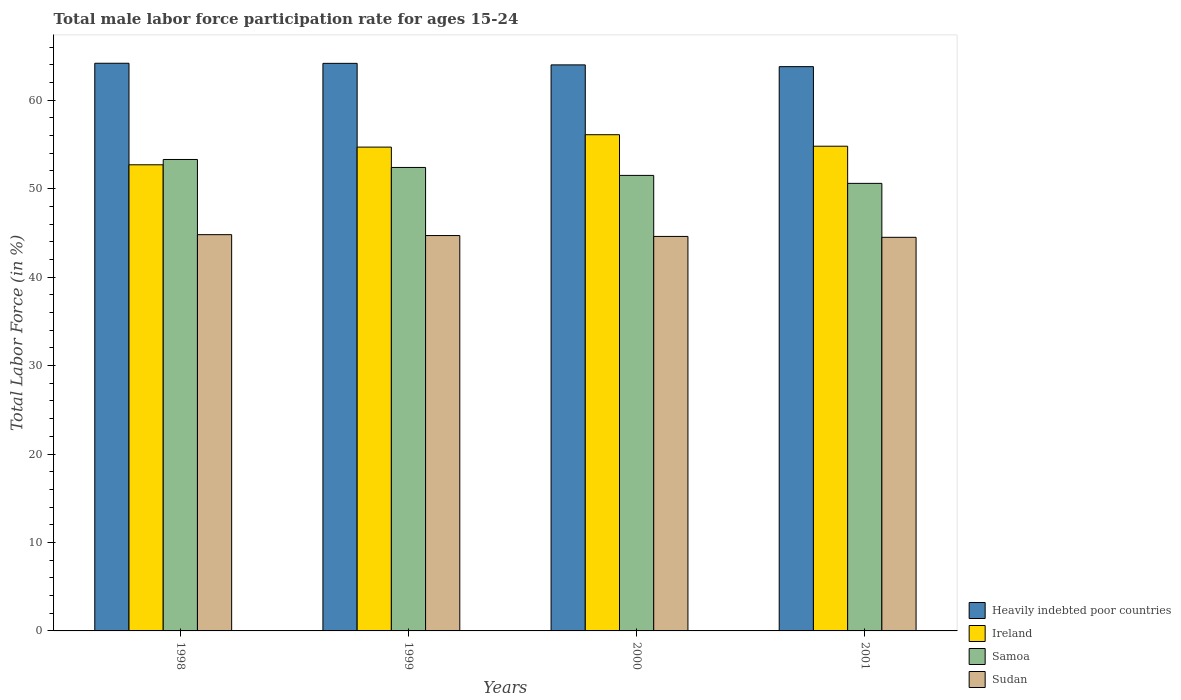How many groups of bars are there?
Make the answer very short. 4. Are the number of bars on each tick of the X-axis equal?
Give a very brief answer. Yes. How many bars are there on the 2nd tick from the right?
Your response must be concise. 4. In how many cases, is the number of bars for a given year not equal to the number of legend labels?
Your response must be concise. 0. What is the male labor force participation rate in Sudan in 1999?
Offer a very short reply. 44.7. Across all years, what is the maximum male labor force participation rate in Samoa?
Your response must be concise. 53.3. Across all years, what is the minimum male labor force participation rate in Heavily indebted poor countries?
Give a very brief answer. 63.8. In which year was the male labor force participation rate in Sudan minimum?
Offer a terse response. 2001. What is the total male labor force participation rate in Sudan in the graph?
Offer a terse response. 178.6. What is the difference between the male labor force participation rate in Ireland in 1999 and that in 2000?
Your answer should be very brief. -1.4. What is the difference between the male labor force participation rate in Ireland in 1998 and the male labor force participation rate in Samoa in 2001?
Keep it short and to the point. 2.1. What is the average male labor force participation rate in Ireland per year?
Provide a short and direct response. 54.57. In the year 1998, what is the difference between the male labor force participation rate in Heavily indebted poor countries and male labor force participation rate in Samoa?
Offer a very short reply. 10.88. In how many years, is the male labor force participation rate in Ireland greater than 48 %?
Ensure brevity in your answer.  4. What is the ratio of the male labor force participation rate in Ireland in 2000 to that in 2001?
Provide a succinct answer. 1.02. Is the male labor force participation rate in Ireland in 1998 less than that in 2001?
Ensure brevity in your answer.  Yes. What is the difference between the highest and the second highest male labor force participation rate in Heavily indebted poor countries?
Your answer should be compact. 0.01. What is the difference between the highest and the lowest male labor force participation rate in Ireland?
Ensure brevity in your answer.  3.4. In how many years, is the male labor force participation rate in Samoa greater than the average male labor force participation rate in Samoa taken over all years?
Your response must be concise. 2. Is the sum of the male labor force participation rate in Sudan in 1998 and 2001 greater than the maximum male labor force participation rate in Ireland across all years?
Your answer should be compact. Yes. What does the 3rd bar from the left in 1999 represents?
Provide a short and direct response. Samoa. What does the 3rd bar from the right in 2000 represents?
Provide a short and direct response. Ireland. How many bars are there?
Your answer should be compact. 16. What is the difference between two consecutive major ticks on the Y-axis?
Your answer should be compact. 10. Where does the legend appear in the graph?
Your answer should be very brief. Bottom right. How many legend labels are there?
Ensure brevity in your answer.  4. What is the title of the graph?
Provide a short and direct response. Total male labor force participation rate for ages 15-24. What is the label or title of the X-axis?
Offer a terse response. Years. What is the label or title of the Y-axis?
Give a very brief answer. Total Labor Force (in %). What is the Total Labor Force (in %) of Heavily indebted poor countries in 1998?
Make the answer very short. 64.18. What is the Total Labor Force (in %) of Ireland in 1998?
Your answer should be compact. 52.7. What is the Total Labor Force (in %) of Samoa in 1998?
Keep it short and to the point. 53.3. What is the Total Labor Force (in %) of Sudan in 1998?
Give a very brief answer. 44.8. What is the Total Labor Force (in %) in Heavily indebted poor countries in 1999?
Offer a very short reply. 64.17. What is the Total Labor Force (in %) of Ireland in 1999?
Your answer should be compact. 54.7. What is the Total Labor Force (in %) of Samoa in 1999?
Provide a succinct answer. 52.4. What is the Total Labor Force (in %) in Sudan in 1999?
Ensure brevity in your answer.  44.7. What is the Total Labor Force (in %) in Heavily indebted poor countries in 2000?
Keep it short and to the point. 63.99. What is the Total Labor Force (in %) in Ireland in 2000?
Your response must be concise. 56.1. What is the Total Labor Force (in %) of Samoa in 2000?
Give a very brief answer. 51.5. What is the Total Labor Force (in %) in Sudan in 2000?
Offer a terse response. 44.6. What is the Total Labor Force (in %) in Heavily indebted poor countries in 2001?
Give a very brief answer. 63.8. What is the Total Labor Force (in %) of Ireland in 2001?
Provide a succinct answer. 54.8. What is the Total Labor Force (in %) in Samoa in 2001?
Your answer should be compact. 50.6. What is the Total Labor Force (in %) of Sudan in 2001?
Provide a short and direct response. 44.5. Across all years, what is the maximum Total Labor Force (in %) of Heavily indebted poor countries?
Offer a very short reply. 64.18. Across all years, what is the maximum Total Labor Force (in %) of Ireland?
Give a very brief answer. 56.1. Across all years, what is the maximum Total Labor Force (in %) of Samoa?
Provide a short and direct response. 53.3. Across all years, what is the maximum Total Labor Force (in %) of Sudan?
Offer a terse response. 44.8. Across all years, what is the minimum Total Labor Force (in %) in Heavily indebted poor countries?
Your answer should be compact. 63.8. Across all years, what is the minimum Total Labor Force (in %) in Ireland?
Keep it short and to the point. 52.7. Across all years, what is the minimum Total Labor Force (in %) of Samoa?
Give a very brief answer. 50.6. Across all years, what is the minimum Total Labor Force (in %) of Sudan?
Keep it short and to the point. 44.5. What is the total Total Labor Force (in %) in Heavily indebted poor countries in the graph?
Give a very brief answer. 256.14. What is the total Total Labor Force (in %) in Ireland in the graph?
Your answer should be compact. 218.3. What is the total Total Labor Force (in %) of Samoa in the graph?
Make the answer very short. 207.8. What is the total Total Labor Force (in %) of Sudan in the graph?
Provide a succinct answer. 178.6. What is the difference between the Total Labor Force (in %) of Heavily indebted poor countries in 1998 and that in 1999?
Offer a very short reply. 0.01. What is the difference between the Total Labor Force (in %) in Heavily indebted poor countries in 1998 and that in 2000?
Your answer should be very brief. 0.18. What is the difference between the Total Labor Force (in %) in Ireland in 1998 and that in 2000?
Your response must be concise. -3.4. What is the difference between the Total Labor Force (in %) of Samoa in 1998 and that in 2000?
Ensure brevity in your answer.  1.8. What is the difference between the Total Labor Force (in %) of Heavily indebted poor countries in 1998 and that in 2001?
Your response must be concise. 0.38. What is the difference between the Total Labor Force (in %) of Ireland in 1998 and that in 2001?
Offer a very short reply. -2.1. What is the difference between the Total Labor Force (in %) in Heavily indebted poor countries in 1999 and that in 2000?
Provide a succinct answer. 0.17. What is the difference between the Total Labor Force (in %) in Samoa in 1999 and that in 2000?
Give a very brief answer. 0.9. What is the difference between the Total Labor Force (in %) of Heavily indebted poor countries in 1999 and that in 2001?
Ensure brevity in your answer.  0.37. What is the difference between the Total Labor Force (in %) in Samoa in 1999 and that in 2001?
Make the answer very short. 1.8. What is the difference between the Total Labor Force (in %) of Heavily indebted poor countries in 2000 and that in 2001?
Your answer should be very brief. 0.2. What is the difference between the Total Labor Force (in %) of Heavily indebted poor countries in 1998 and the Total Labor Force (in %) of Ireland in 1999?
Provide a succinct answer. 9.48. What is the difference between the Total Labor Force (in %) in Heavily indebted poor countries in 1998 and the Total Labor Force (in %) in Samoa in 1999?
Provide a succinct answer. 11.78. What is the difference between the Total Labor Force (in %) of Heavily indebted poor countries in 1998 and the Total Labor Force (in %) of Sudan in 1999?
Provide a short and direct response. 19.48. What is the difference between the Total Labor Force (in %) of Ireland in 1998 and the Total Labor Force (in %) of Samoa in 1999?
Offer a very short reply. 0.3. What is the difference between the Total Labor Force (in %) of Ireland in 1998 and the Total Labor Force (in %) of Sudan in 1999?
Make the answer very short. 8. What is the difference between the Total Labor Force (in %) of Heavily indebted poor countries in 1998 and the Total Labor Force (in %) of Ireland in 2000?
Ensure brevity in your answer.  8.08. What is the difference between the Total Labor Force (in %) of Heavily indebted poor countries in 1998 and the Total Labor Force (in %) of Samoa in 2000?
Provide a succinct answer. 12.68. What is the difference between the Total Labor Force (in %) in Heavily indebted poor countries in 1998 and the Total Labor Force (in %) in Sudan in 2000?
Your response must be concise. 19.58. What is the difference between the Total Labor Force (in %) of Ireland in 1998 and the Total Labor Force (in %) of Samoa in 2000?
Provide a succinct answer. 1.2. What is the difference between the Total Labor Force (in %) of Ireland in 1998 and the Total Labor Force (in %) of Sudan in 2000?
Ensure brevity in your answer.  8.1. What is the difference between the Total Labor Force (in %) of Samoa in 1998 and the Total Labor Force (in %) of Sudan in 2000?
Provide a short and direct response. 8.7. What is the difference between the Total Labor Force (in %) of Heavily indebted poor countries in 1998 and the Total Labor Force (in %) of Ireland in 2001?
Make the answer very short. 9.38. What is the difference between the Total Labor Force (in %) of Heavily indebted poor countries in 1998 and the Total Labor Force (in %) of Samoa in 2001?
Ensure brevity in your answer.  13.58. What is the difference between the Total Labor Force (in %) of Heavily indebted poor countries in 1998 and the Total Labor Force (in %) of Sudan in 2001?
Your answer should be very brief. 19.68. What is the difference between the Total Labor Force (in %) in Ireland in 1998 and the Total Labor Force (in %) in Sudan in 2001?
Make the answer very short. 8.2. What is the difference between the Total Labor Force (in %) in Heavily indebted poor countries in 1999 and the Total Labor Force (in %) in Ireland in 2000?
Give a very brief answer. 8.07. What is the difference between the Total Labor Force (in %) of Heavily indebted poor countries in 1999 and the Total Labor Force (in %) of Samoa in 2000?
Your response must be concise. 12.67. What is the difference between the Total Labor Force (in %) of Heavily indebted poor countries in 1999 and the Total Labor Force (in %) of Sudan in 2000?
Make the answer very short. 19.57. What is the difference between the Total Labor Force (in %) of Ireland in 1999 and the Total Labor Force (in %) of Sudan in 2000?
Provide a short and direct response. 10.1. What is the difference between the Total Labor Force (in %) in Samoa in 1999 and the Total Labor Force (in %) in Sudan in 2000?
Offer a terse response. 7.8. What is the difference between the Total Labor Force (in %) of Heavily indebted poor countries in 1999 and the Total Labor Force (in %) of Ireland in 2001?
Your answer should be compact. 9.37. What is the difference between the Total Labor Force (in %) in Heavily indebted poor countries in 1999 and the Total Labor Force (in %) in Samoa in 2001?
Provide a short and direct response. 13.57. What is the difference between the Total Labor Force (in %) in Heavily indebted poor countries in 1999 and the Total Labor Force (in %) in Sudan in 2001?
Your answer should be compact. 19.67. What is the difference between the Total Labor Force (in %) of Ireland in 1999 and the Total Labor Force (in %) of Samoa in 2001?
Offer a very short reply. 4.1. What is the difference between the Total Labor Force (in %) of Ireland in 1999 and the Total Labor Force (in %) of Sudan in 2001?
Offer a terse response. 10.2. What is the difference between the Total Labor Force (in %) of Heavily indebted poor countries in 2000 and the Total Labor Force (in %) of Ireland in 2001?
Offer a terse response. 9.19. What is the difference between the Total Labor Force (in %) in Heavily indebted poor countries in 2000 and the Total Labor Force (in %) in Samoa in 2001?
Keep it short and to the point. 13.39. What is the difference between the Total Labor Force (in %) of Heavily indebted poor countries in 2000 and the Total Labor Force (in %) of Sudan in 2001?
Your answer should be compact. 19.49. What is the average Total Labor Force (in %) of Heavily indebted poor countries per year?
Your answer should be compact. 64.03. What is the average Total Labor Force (in %) of Ireland per year?
Make the answer very short. 54.58. What is the average Total Labor Force (in %) in Samoa per year?
Your answer should be very brief. 51.95. What is the average Total Labor Force (in %) of Sudan per year?
Your response must be concise. 44.65. In the year 1998, what is the difference between the Total Labor Force (in %) in Heavily indebted poor countries and Total Labor Force (in %) in Ireland?
Offer a terse response. 11.48. In the year 1998, what is the difference between the Total Labor Force (in %) in Heavily indebted poor countries and Total Labor Force (in %) in Samoa?
Offer a very short reply. 10.88. In the year 1998, what is the difference between the Total Labor Force (in %) in Heavily indebted poor countries and Total Labor Force (in %) in Sudan?
Your response must be concise. 19.38. In the year 1998, what is the difference between the Total Labor Force (in %) in Ireland and Total Labor Force (in %) in Samoa?
Keep it short and to the point. -0.6. In the year 1998, what is the difference between the Total Labor Force (in %) in Samoa and Total Labor Force (in %) in Sudan?
Give a very brief answer. 8.5. In the year 1999, what is the difference between the Total Labor Force (in %) in Heavily indebted poor countries and Total Labor Force (in %) in Ireland?
Your response must be concise. 9.47. In the year 1999, what is the difference between the Total Labor Force (in %) in Heavily indebted poor countries and Total Labor Force (in %) in Samoa?
Offer a terse response. 11.77. In the year 1999, what is the difference between the Total Labor Force (in %) of Heavily indebted poor countries and Total Labor Force (in %) of Sudan?
Your answer should be compact. 19.47. In the year 1999, what is the difference between the Total Labor Force (in %) in Ireland and Total Labor Force (in %) in Sudan?
Give a very brief answer. 10. In the year 1999, what is the difference between the Total Labor Force (in %) of Samoa and Total Labor Force (in %) of Sudan?
Ensure brevity in your answer.  7.7. In the year 2000, what is the difference between the Total Labor Force (in %) in Heavily indebted poor countries and Total Labor Force (in %) in Ireland?
Make the answer very short. 7.89. In the year 2000, what is the difference between the Total Labor Force (in %) in Heavily indebted poor countries and Total Labor Force (in %) in Samoa?
Keep it short and to the point. 12.49. In the year 2000, what is the difference between the Total Labor Force (in %) in Heavily indebted poor countries and Total Labor Force (in %) in Sudan?
Ensure brevity in your answer.  19.39. In the year 2000, what is the difference between the Total Labor Force (in %) of Ireland and Total Labor Force (in %) of Samoa?
Give a very brief answer. 4.6. In the year 2000, what is the difference between the Total Labor Force (in %) in Samoa and Total Labor Force (in %) in Sudan?
Provide a short and direct response. 6.9. In the year 2001, what is the difference between the Total Labor Force (in %) in Heavily indebted poor countries and Total Labor Force (in %) in Ireland?
Offer a terse response. 9. In the year 2001, what is the difference between the Total Labor Force (in %) in Heavily indebted poor countries and Total Labor Force (in %) in Samoa?
Make the answer very short. 13.2. In the year 2001, what is the difference between the Total Labor Force (in %) in Heavily indebted poor countries and Total Labor Force (in %) in Sudan?
Provide a succinct answer. 19.3. In the year 2001, what is the difference between the Total Labor Force (in %) of Ireland and Total Labor Force (in %) of Samoa?
Offer a terse response. 4.2. In the year 2001, what is the difference between the Total Labor Force (in %) in Ireland and Total Labor Force (in %) in Sudan?
Make the answer very short. 10.3. What is the ratio of the Total Labor Force (in %) in Heavily indebted poor countries in 1998 to that in 1999?
Provide a short and direct response. 1. What is the ratio of the Total Labor Force (in %) of Ireland in 1998 to that in 1999?
Keep it short and to the point. 0.96. What is the ratio of the Total Labor Force (in %) of Samoa in 1998 to that in 1999?
Your response must be concise. 1.02. What is the ratio of the Total Labor Force (in %) of Ireland in 1998 to that in 2000?
Ensure brevity in your answer.  0.94. What is the ratio of the Total Labor Force (in %) in Samoa in 1998 to that in 2000?
Provide a succinct answer. 1.03. What is the ratio of the Total Labor Force (in %) in Sudan in 1998 to that in 2000?
Ensure brevity in your answer.  1. What is the ratio of the Total Labor Force (in %) in Ireland in 1998 to that in 2001?
Provide a short and direct response. 0.96. What is the ratio of the Total Labor Force (in %) in Samoa in 1998 to that in 2001?
Your response must be concise. 1.05. What is the ratio of the Total Labor Force (in %) of Sudan in 1998 to that in 2001?
Provide a short and direct response. 1.01. What is the ratio of the Total Labor Force (in %) in Samoa in 1999 to that in 2000?
Your answer should be very brief. 1.02. What is the ratio of the Total Labor Force (in %) of Heavily indebted poor countries in 1999 to that in 2001?
Provide a short and direct response. 1.01. What is the ratio of the Total Labor Force (in %) in Ireland in 1999 to that in 2001?
Give a very brief answer. 1. What is the ratio of the Total Labor Force (in %) of Samoa in 1999 to that in 2001?
Make the answer very short. 1.04. What is the ratio of the Total Labor Force (in %) in Sudan in 1999 to that in 2001?
Provide a succinct answer. 1. What is the ratio of the Total Labor Force (in %) in Ireland in 2000 to that in 2001?
Your answer should be very brief. 1.02. What is the ratio of the Total Labor Force (in %) in Samoa in 2000 to that in 2001?
Your answer should be very brief. 1.02. What is the difference between the highest and the second highest Total Labor Force (in %) in Heavily indebted poor countries?
Keep it short and to the point. 0.01. What is the difference between the highest and the second highest Total Labor Force (in %) of Ireland?
Provide a succinct answer. 1.3. What is the difference between the highest and the second highest Total Labor Force (in %) of Sudan?
Keep it short and to the point. 0.1. What is the difference between the highest and the lowest Total Labor Force (in %) in Heavily indebted poor countries?
Ensure brevity in your answer.  0.38. What is the difference between the highest and the lowest Total Labor Force (in %) of Ireland?
Provide a short and direct response. 3.4. What is the difference between the highest and the lowest Total Labor Force (in %) of Sudan?
Your answer should be compact. 0.3. 